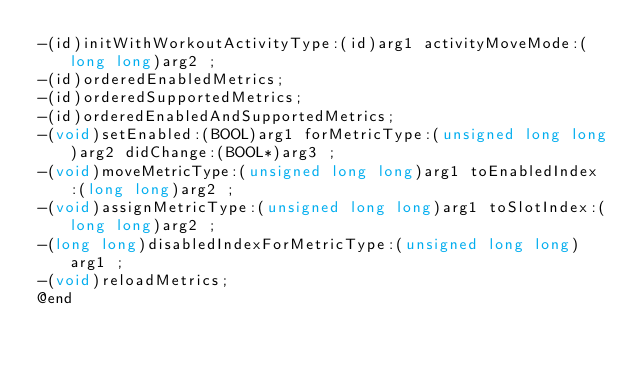Convert code to text. <code><loc_0><loc_0><loc_500><loc_500><_C_>-(id)initWithWorkoutActivityType:(id)arg1 activityMoveMode:(long long)arg2 ;
-(id)orderedEnabledMetrics;
-(id)orderedSupportedMetrics;
-(id)orderedEnabledAndSupportedMetrics;
-(void)setEnabled:(BOOL)arg1 forMetricType:(unsigned long long)arg2 didChange:(BOOL*)arg3 ;
-(void)moveMetricType:(unsigned long long)arg1 toEnabledIndex:(long long)arg2 ;
-(void)assignMetricType:(unsigned long long)arg1 toSlotIndex:(long long)arg2 ;
-(long long)disabledIndexForMetricType:(unsigned long long)arg1 ;
-(void)reloadMetrics;
@end

</code> 